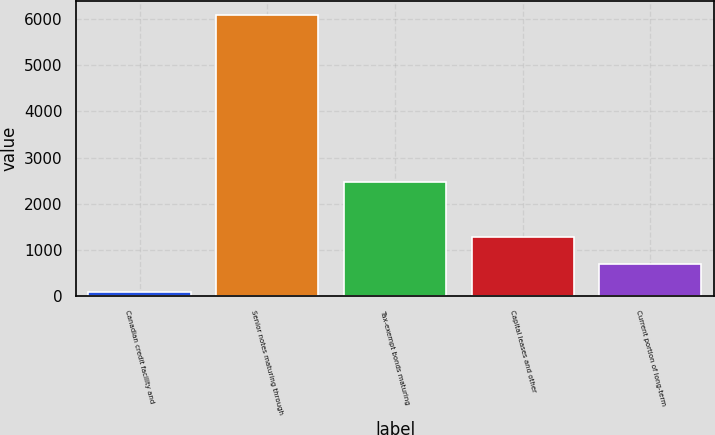Convert chart. <chart><loc_0><loc_0><loc_500><loc_500><bar_chart><fcel>Canadian credit facility and<fcel>Senior notes maturing through<fcel>Tax-exempt bonds maturing<fcel>Capital leases and other<fcel>Current portion of long-term<nl><fcel>84<fcel>6082<fcel>2467<fcel>1283.6<fcel>683.8<nl></chart> 